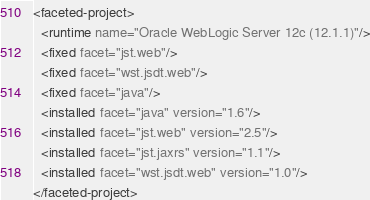<code> <loc_0><loc_0><loc_500><loc_500><_XML_><faceted-project>
  <runtime name="Oracle WebLogic Server 12c (12.1.1)"/>
  <fixed facet="jst.web"/>
  <fixed facet="wst.jsdt.web"/>
  <fixed facet="java"/>
  <installed facet="java" version="1.6"/>
  <installed facet="jst.web" version="2.5"/>
  <installed facet="jst.jaxrs" version="1.1"/>
  <installed facet="wst.jsdt.web" version="1.0"/>
</faceted-project>
</code> 